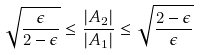Convert formula to latex. <formula><loc_0><loc_0><loc_500><loc_500>\sqrt { \frac { \epsilon } { 2 - \epsilon } } \leq \frac { | A _ { 2 } | } { | A _ { 1 } | } \leq \sqrt { \frac { 2 - \epsilon } { \epsilon } }</formula> 